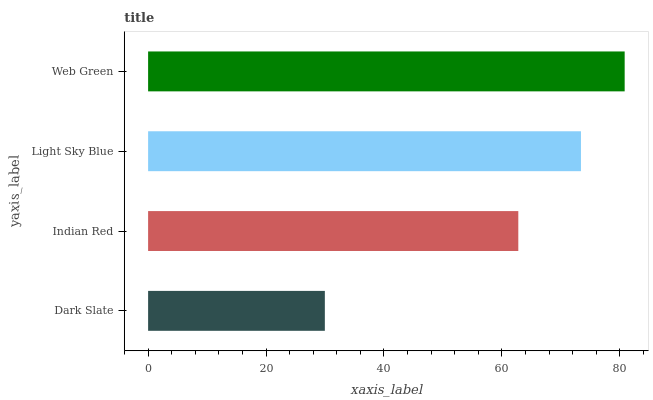Is Dark Slate the minimum?
Answer yes or no. Yes. Is Web Green the maximum?
Answer yes or no. Yes. Is Indian Red the minimum?
Answer yes or no. No. Is Indian Red the maximum?
Answer yes or no. No. Is Indian Red greater than Dark Slate?
Answer yes or no. Yes. Is Dark Slate less than Indian Red?
Answer yes or no. Yes. Is Dark Slate greater than Indian Red?
Answer yes or no. No. Is Indian Red less than Dark Slate?
Answer yes or no. No. Is Light Sky Blue the high median?
Answer yes or no. Yes. Is Indian Red the low median?
Answer yes or no. Yes. Is Web Green the high median?
Answer yes or no. No. Is Light Sky Blue the low median?
Answer yes or no. No. 